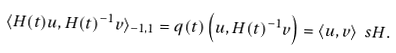<formula> <loc_0><loc_0><loc_500><loc_500>\langle H ( t ) u , H ( t ) ^ { - 1 } v \rangle _ { - 1 , 1 } = q ( t ) \left ( u , H ( t ) ^ { - 1 } v \right ) = \langle u , v \rangle _ { \ } s H .</formula> 